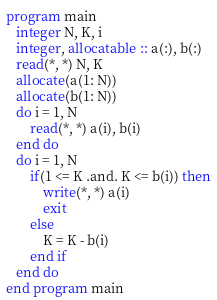Convert code to text. <code><loc_0><loc_0><loc_500><loc_500><_FORTRAN_>program main
   integer N, K, i
   integer, allocatable :: a(:), b(:)
   read(*, *) N, K
   allocate(a(1: N))
   allocate(b(1: N))
   do i = 1, N
       read(*, *) a(i), b(i)
   end do
   do i = 1, N
       if(1 <= K .and. K <= b(i)) then
	       write(*, *) a(i)
	       exit
	   else
	       K = K - b(i)
	   end if
   end do
end program main</code> 